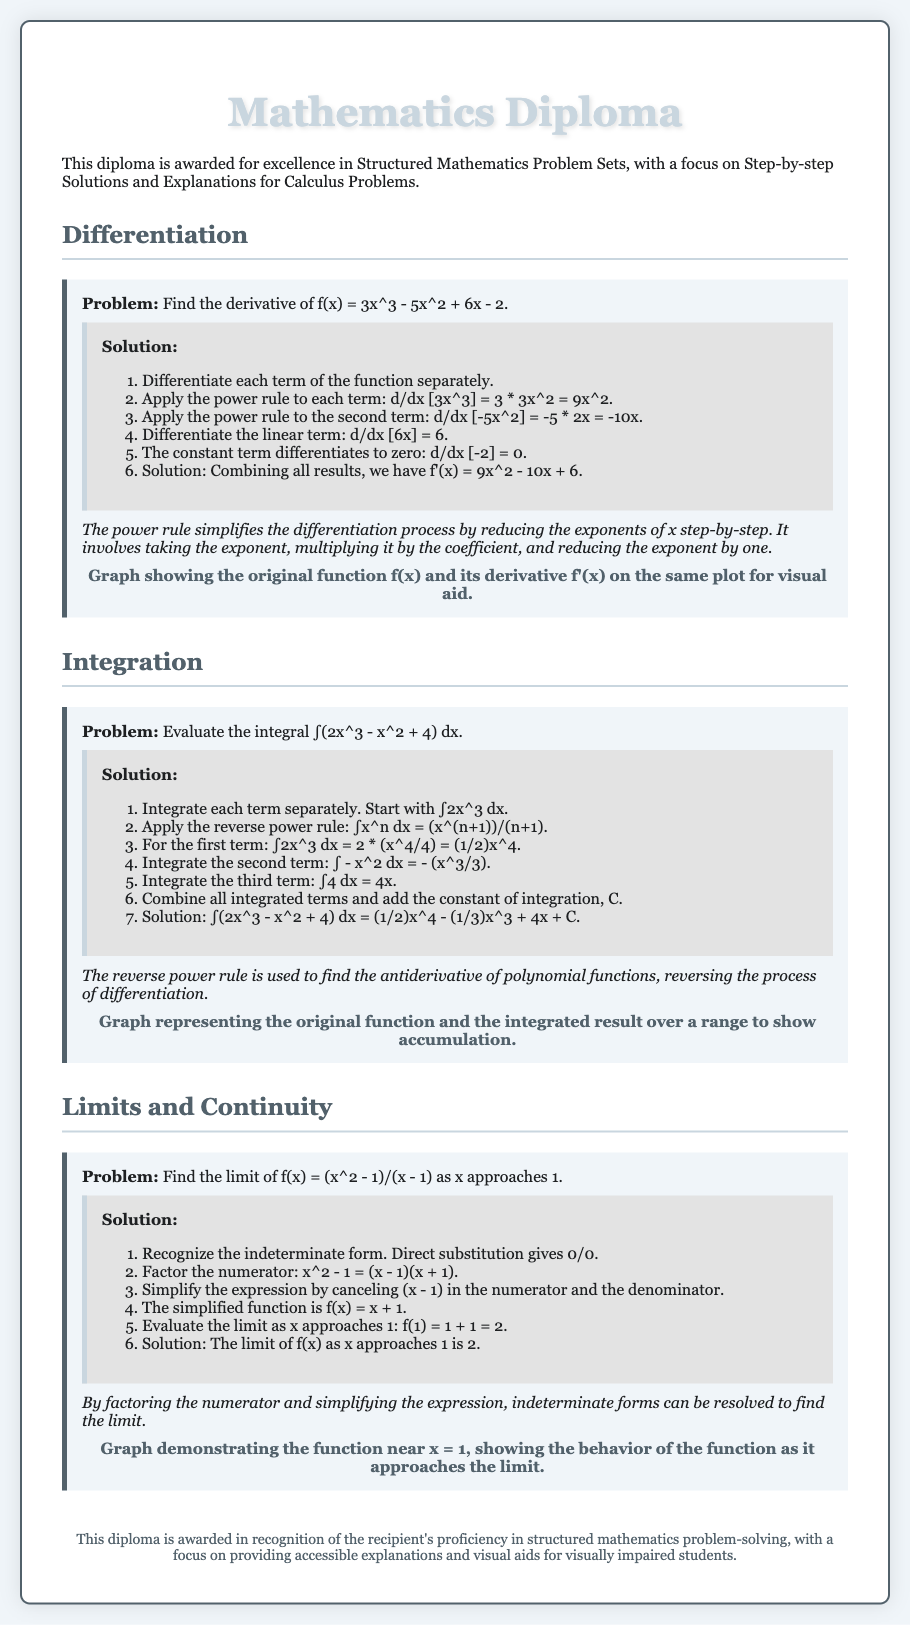What is the title of the document? The title is prominently displayed at the top of the document, indicating its focus on mathematics.
Answer: Mathematics Diploma What is the first problem discussed in the document? The first problem is related to finding the derivative of a function.
Answer: Find the derivative of f(x) = 3x^3 - 5x^2 + 6x - 2 What is the final answer for the derivative in the document? The document combines the results of differentiation into one expression.
Answer: f'(x) = 9x^2 - 10x + 6 What method is used to evaluate the integral in the second problem? The document describes a specific technique for integrating polynomials.
Answer: Reverse power rule What is the limit of f(x) as x approaches 1? The document provides a step-by-step evaluation of the limit, leading to a specific answer.
Answer: 2 What does the graph in the differentiation section illustrate? The document mentions that the graph serves as a visual aid for understanding the relationship between the original function and its derivative.
Answer: Original function f(x) and its derivative f'(x) What is a common form that arises when finding limits in the problems? The document specifically mentions a type of outcome encountered during limit evaluation.
Answer: Indeterminate form What is one of the key focuses of this diploma as stated in the conclusion? The diploma emphasizes an important aspect of mathematics education, particularly for accessibility.
Answer: Accessible explanations and visual aids 